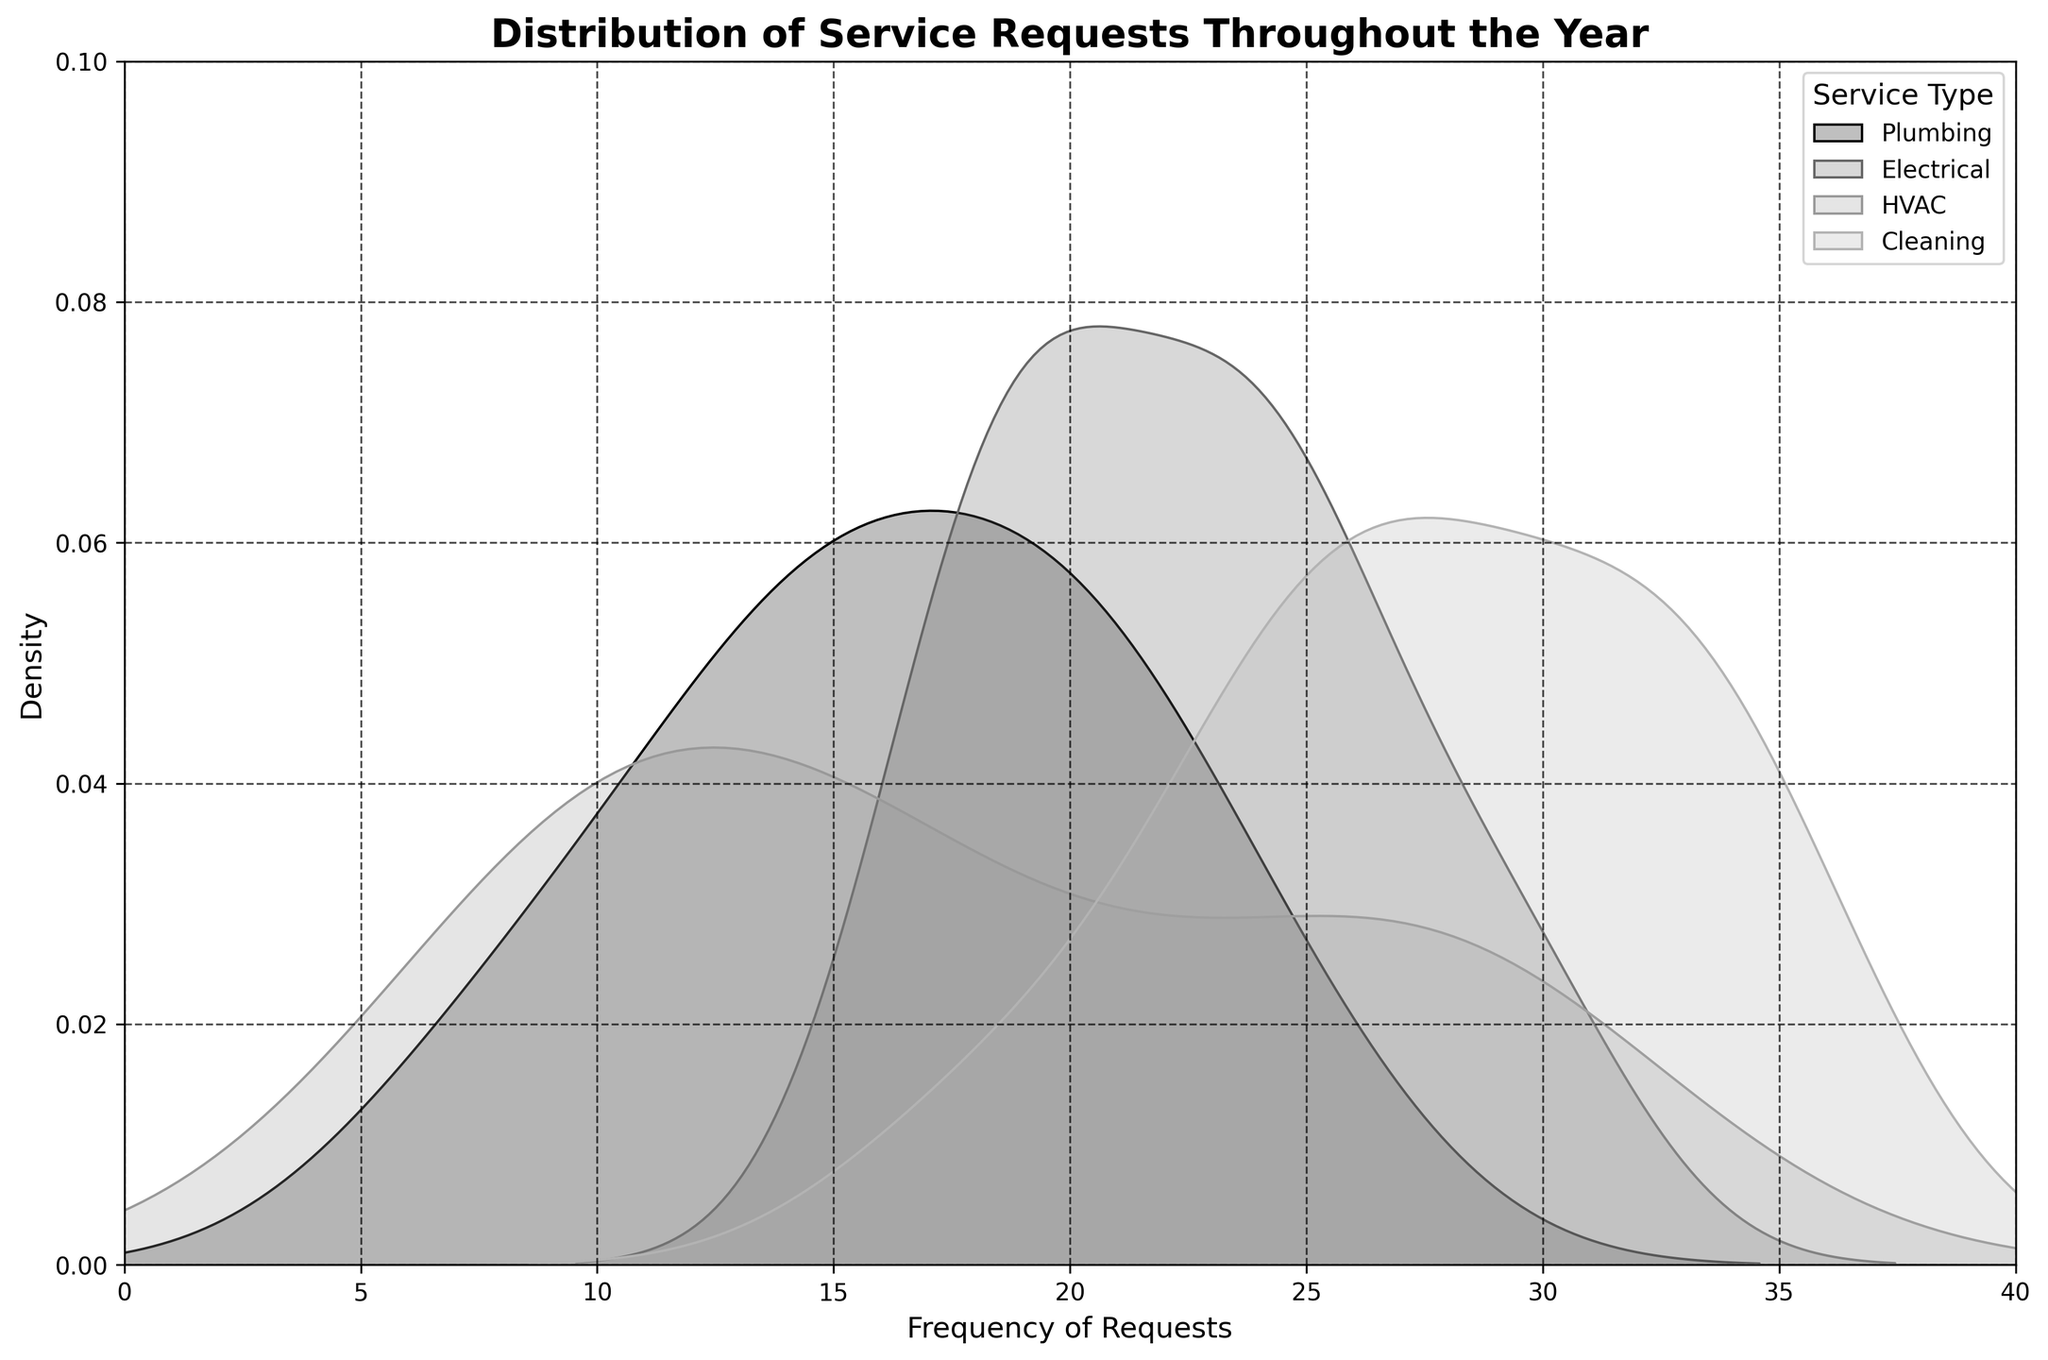What is the title of the figure? The title of the figure is prominently displayed at the top of the plot. It helps in quickly comprehending the subject matter of the visual representation.
Answer: Distribution of Service Requests Throughout the Year What are the labels for the x and y axes? The x-axis label indicates what is being measured or analyzed horizontally, while the y-axis label shows the vertical measurement.
Answer: The x-axis is labeled 'Frequency of Requests' and the y-axis is labeled 'Density' Which service type has the highest peak density? By observing the curves in the distplot, you can identify which one reaches the highest point on the y-axis, indicating the highest peak density.
Answer: Cleaning Which service type shows the broadest distribution across the frequency of requests? A broader distribution can be identified by observing which curve spans the widest range on the x-axis.
Answer: Cleaning On average, how does the frequency of Plumbing services compare to Electrical services? To answer this, compare their respective distributions' central tendencies by visually estimating the mean frequency where the curves have their significant densities.
Answer: Plumbing generally has a lower frequency than Electrical During which months might HVAC services experience a higher demand compared to Plumbing services? Analyze the density curves for both HVAC and Plumbing services and identify periods where HVAC's frequency densities peak higher than Plumbing.
Answer: June, July, August, and May Which service type appears most consistently throughout the year based on the density plot? The plot with the most uniform and least variable distribution (less fluctuation in density) across the x-axis indicates consistent demand.
Answer: HVAC Is there a time of year where Cleaning services demand significantly spikes? By observing the density curve for Cleaning, identify any periods where there is a sharp increase in the density value.
Answer: July In which frequency range are Electrical services most densely requested? Look for the range on the x-axis where the density curve for Electrical is highest.
Answer: 20-30 requests Do all service types show a similar pattern in their frequency distribution? To answer this, compare the shapes and spread of the curves for each service type to see if there's a common trend or if they differ significantly.
Answer: No, they show different patterns 